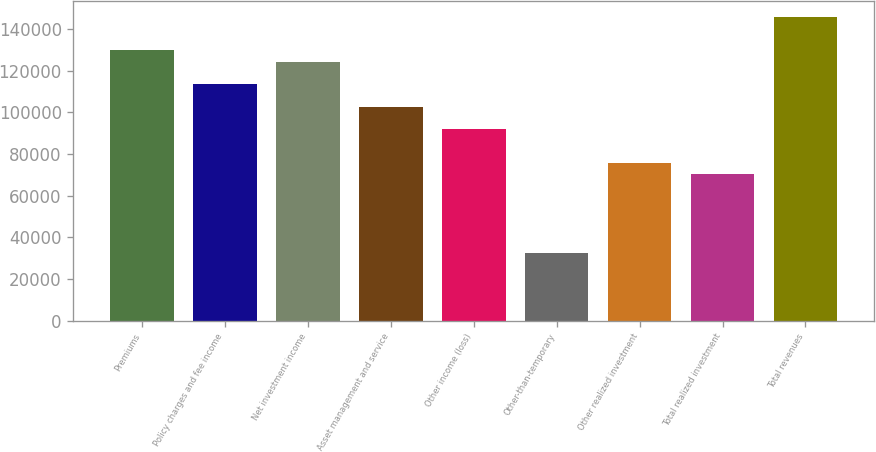Convert chart. <chart><loc_0><loc_0><loc_500><loc_500><bar_chart><fcel>Premiums<fcel>Policy charges and fee income<fcel>Net investment income<fcel>Asset management and service<fcel>Other income (loss)<fcel>Other-than-temporary<fcel>Other realized investment<fcel>Total realized investment<fcel>Total revenues<nl><fcel>129849<fcel>113618<fcel>124439<fcel>102797<fcel>91976.9<fcel>32463.8<fcel>75746.1<fcel>70335.8<fcel>146080<nl></chart> 